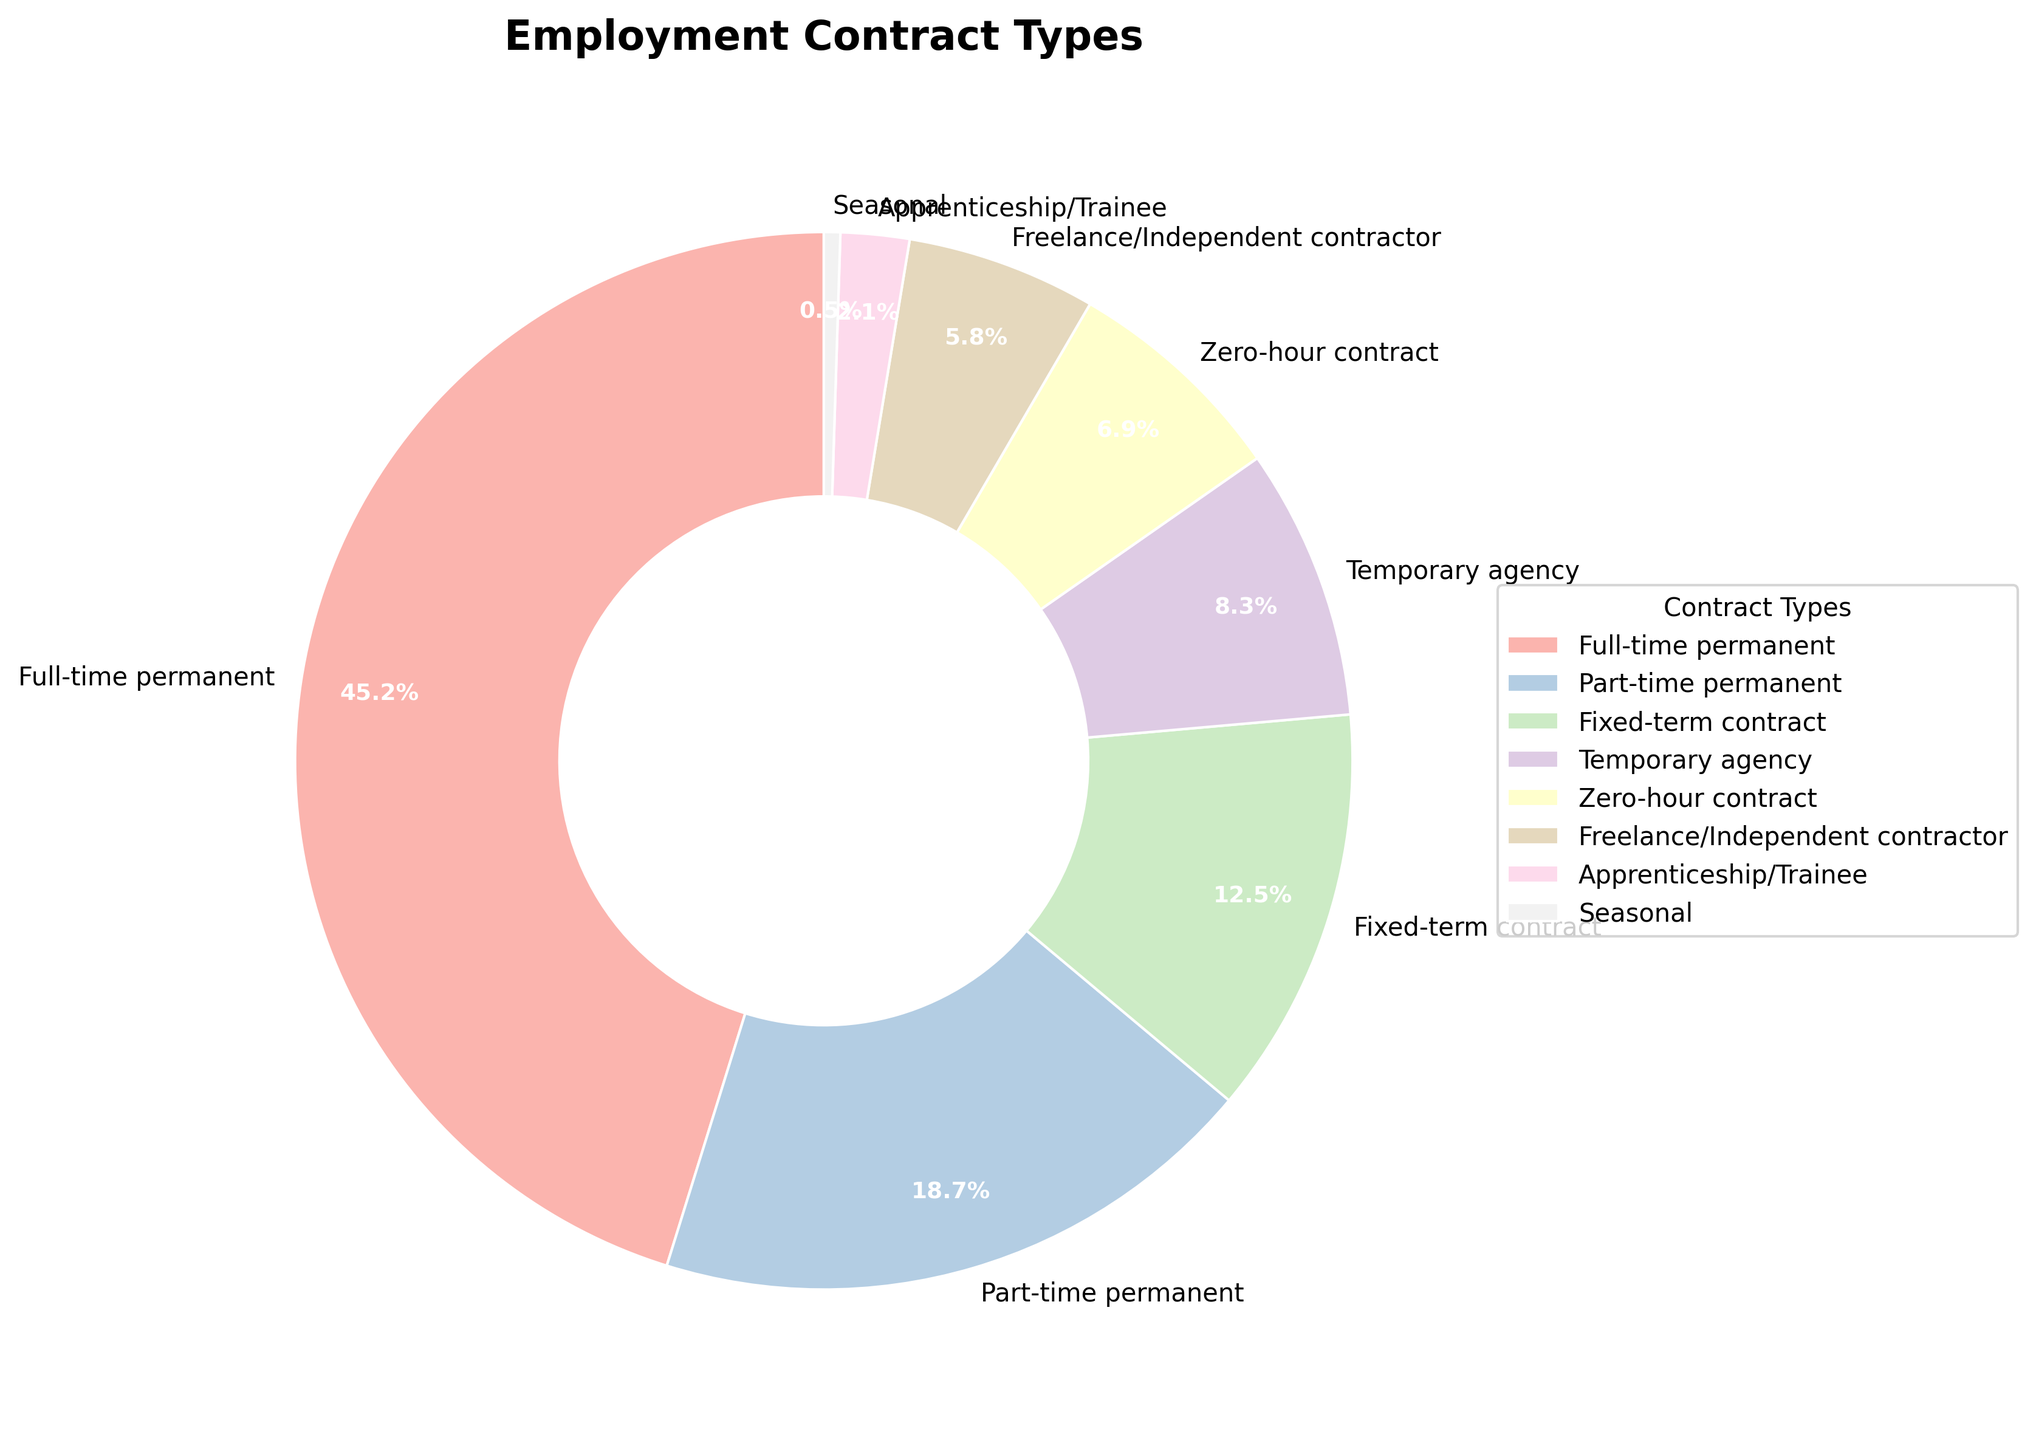Which contract type has the highest percentage of workers? To determine this, look at the slices and their corresponding percentages. The slice with 45.2% matches "Full-time permanent."
Answer: Full-time permanent Which contract type has the smallest number of workers? This requires identifying the smallest slice. The slice labeled "Seasonal" represents 0.5%, the smallest percentage.
Answer: Seasonal What is the combined percentage of workers with permanent contracts (full-time and part-time)? Add the percentages of "Full-time permanent" (45.2%) and "Part-time permanent" (18.7%). The sum is 45.2 + 18.7 = 63.9.
Answer: 63.9% Are there more workers on zero-hour contracts or fixed-term contracts? Compare the slices labeled "Zero-hour contract" (6.9%) and "Fixed-term contract" (12.5%). 6.9 is less than 12.5.
Answer: Fixed-term contract What is the difference between the percentage of workers on temporary agency contracts and freelance/independent contractor contracts? Subtract the percentage of "Freelance/Independent contractor" (5.8%) from "Temporary agency" (8.3%). 8.3 - 5.8 = 2.5.
Answer: 2.5% How does the percentage of part-time permanent contracts compare to zero-hour contracts? Compare the slices labeled "Part-time permanent" (18.7%) and "Zero-hour contract" (6.9%). 18.7 is greater than 6.9.
Answer: Part-time permanent is higher Which contract types cover more than 10% of workers each? Identify the slices with percentages greater than 10%. "Full-time permanent" (45.2%) and "Part-time permanent" (18.7%) both exceed 10%.
Answer: Full-time permanent, Part-time permanent Is the percentage of workers on fixed-term contracts or temporary agency contracts higher than that of zero-hour and freelance contracts combined? First, combine "Zero-hour contract" (6.9%) and "Freelance/Independent contractor" (5.8%). 6.9 + 5.8 = 12.7. Then compare each of "Fixed-term contract" (12.5%) and "Temporary agency" (8.3%) individually against 12.7. Both are less than 12.7.
Answer: No What is the total percentage of workers on flexible employment (zero-hour contracts, freelance, and temporary agency)? Add the percentages for "Zero-hour contract" (6.9%), "Freelance/Independent contractor" (5.8%), and "Temporary agency" (8.3%). 6.9 + 5.8 + 8.3 = 21.
Answer: 21% What is the average percentage of the three least common types of contracts? Add the percentages of "Seasonal" (0.5%), "Apprenticeship/Trainee" (2.1%), and "Freelance/Independent contractor" (5.8%), and then divide by 3. (0.5 + 2.1 + 5.8) / 3 = 2.8.
Answer: 2.8% 